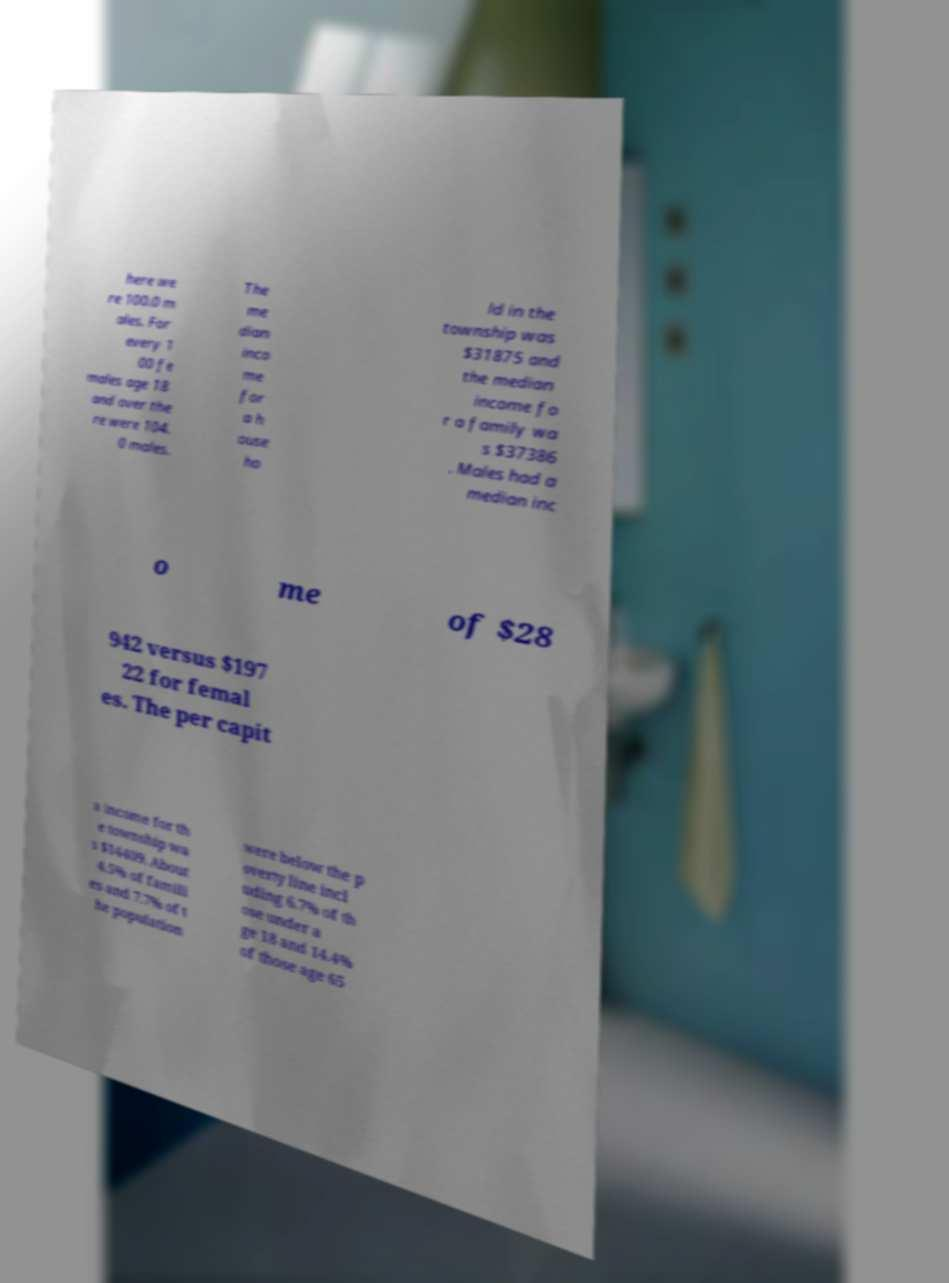There's text embedded in this image that I need extracted. Can you transcribe it verbatim? here we re 100.0 m ales. For every 1 00 fe males age 18 and over the re were 104. 0 males. The me dian inco me for a h ouse ho ld in the township was $31875 and the median income fo r a family wa s $37386 . Males had a median inc o me of $28 942 versus $197 22 for femal es. The per capit a income for th e township wa s $14409. About 4.5% of famili es and 7.7% of t he population were below the p overty line incl uding 6.7% of th ose under a ge 18 and 14.4% of those age 65 